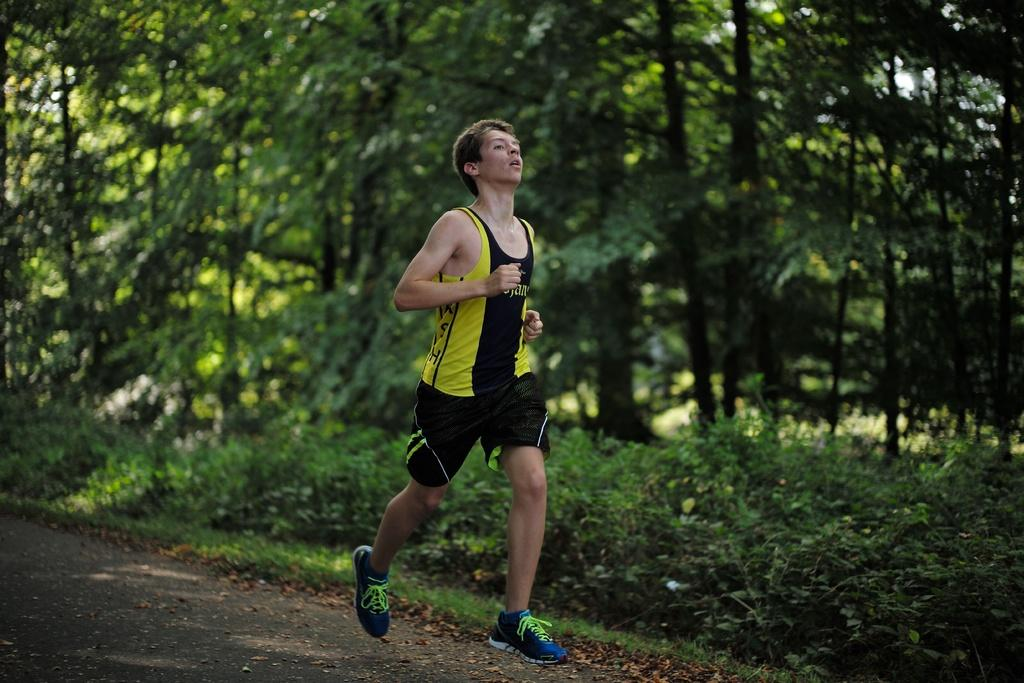What is the man in the image doing? The man is running in the image. On what surface is the man running? The man is running on a road. What type of natural environment can be seen in the image? There is grass, plants, and trees visible in the image. What type of copper material can be seen in the image? There is no copper material present in the image. How many ants can be seen running alongside the man in the image? There are no ants visible in the image; it only features a man running on a road. 